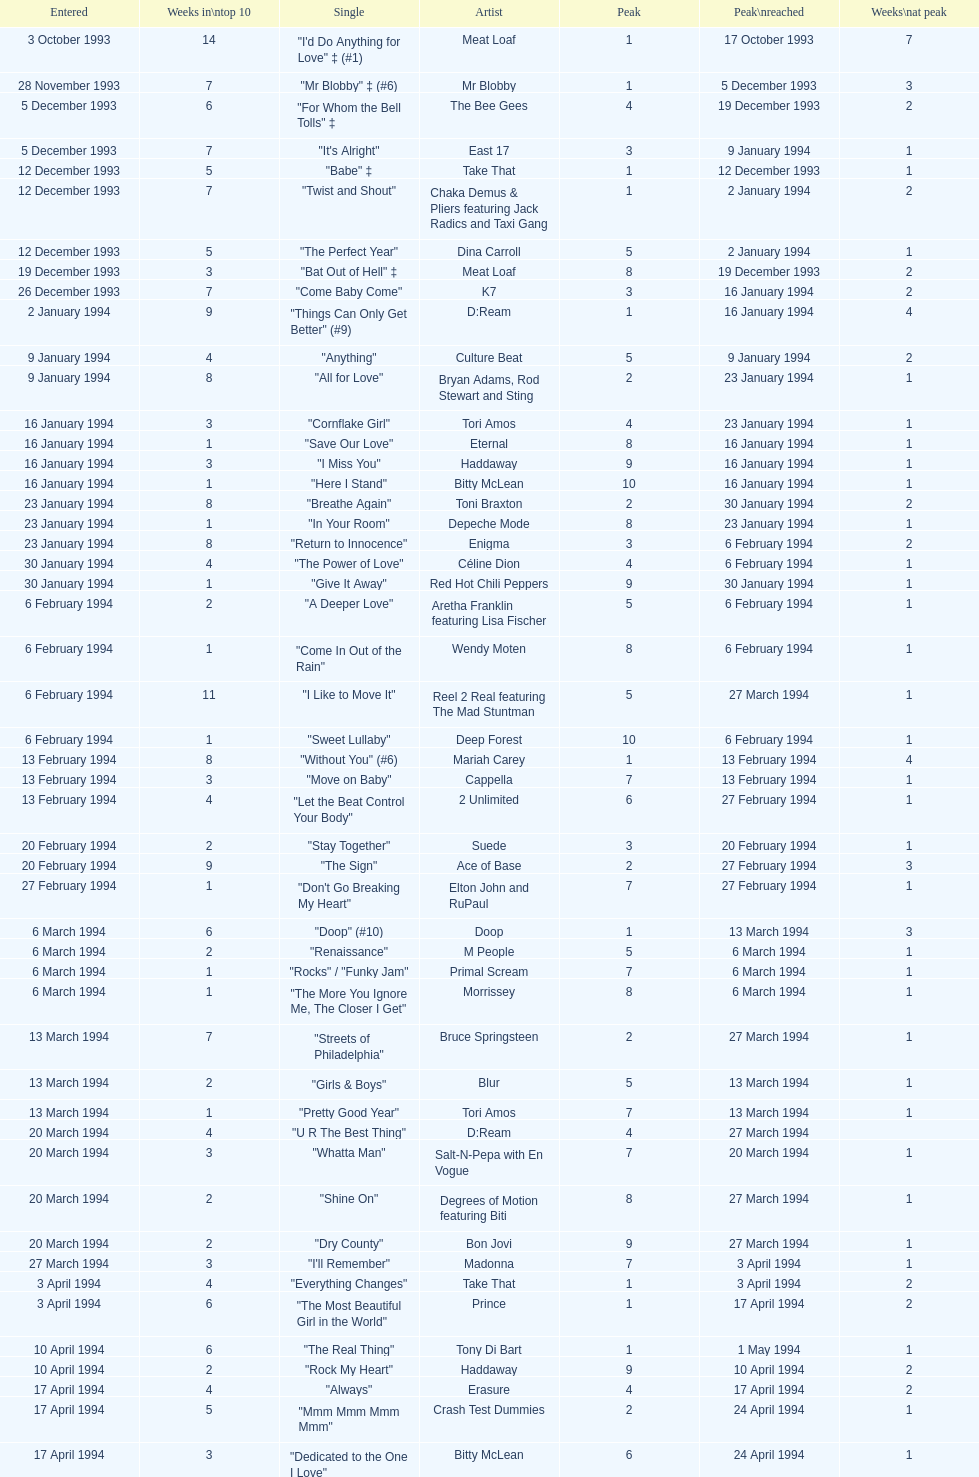What is the initial recorded date? 3 October 1993. 